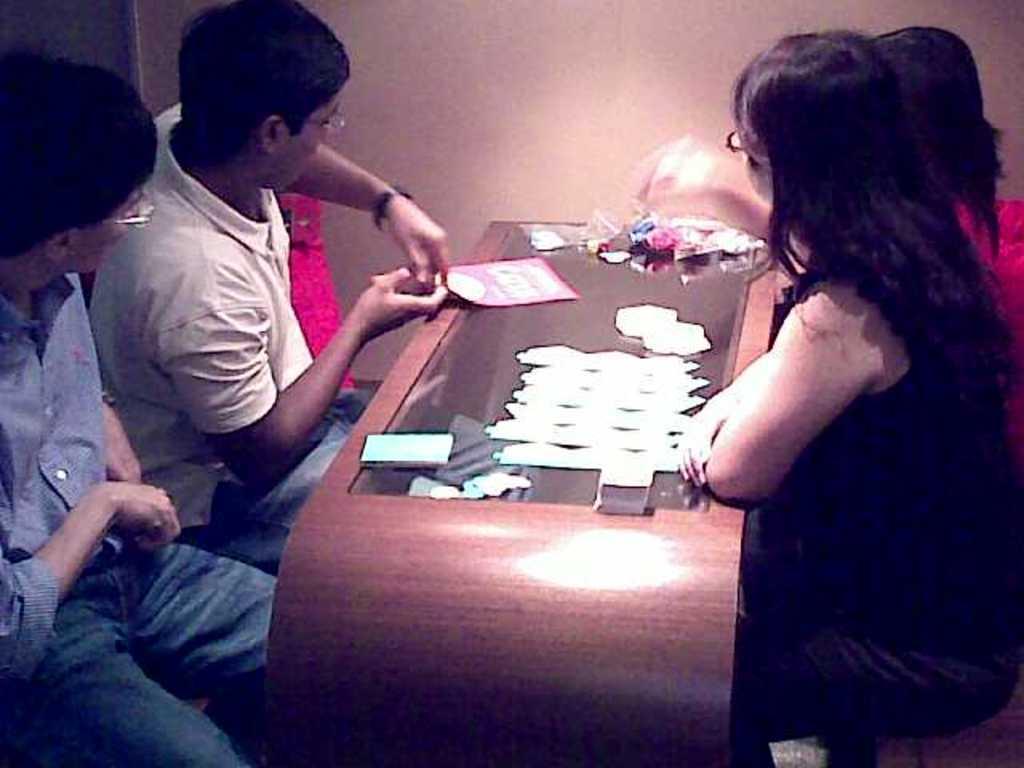Can you describe this image briefly? In this image we can see this people are sitting near the table. There are some things on the table. 